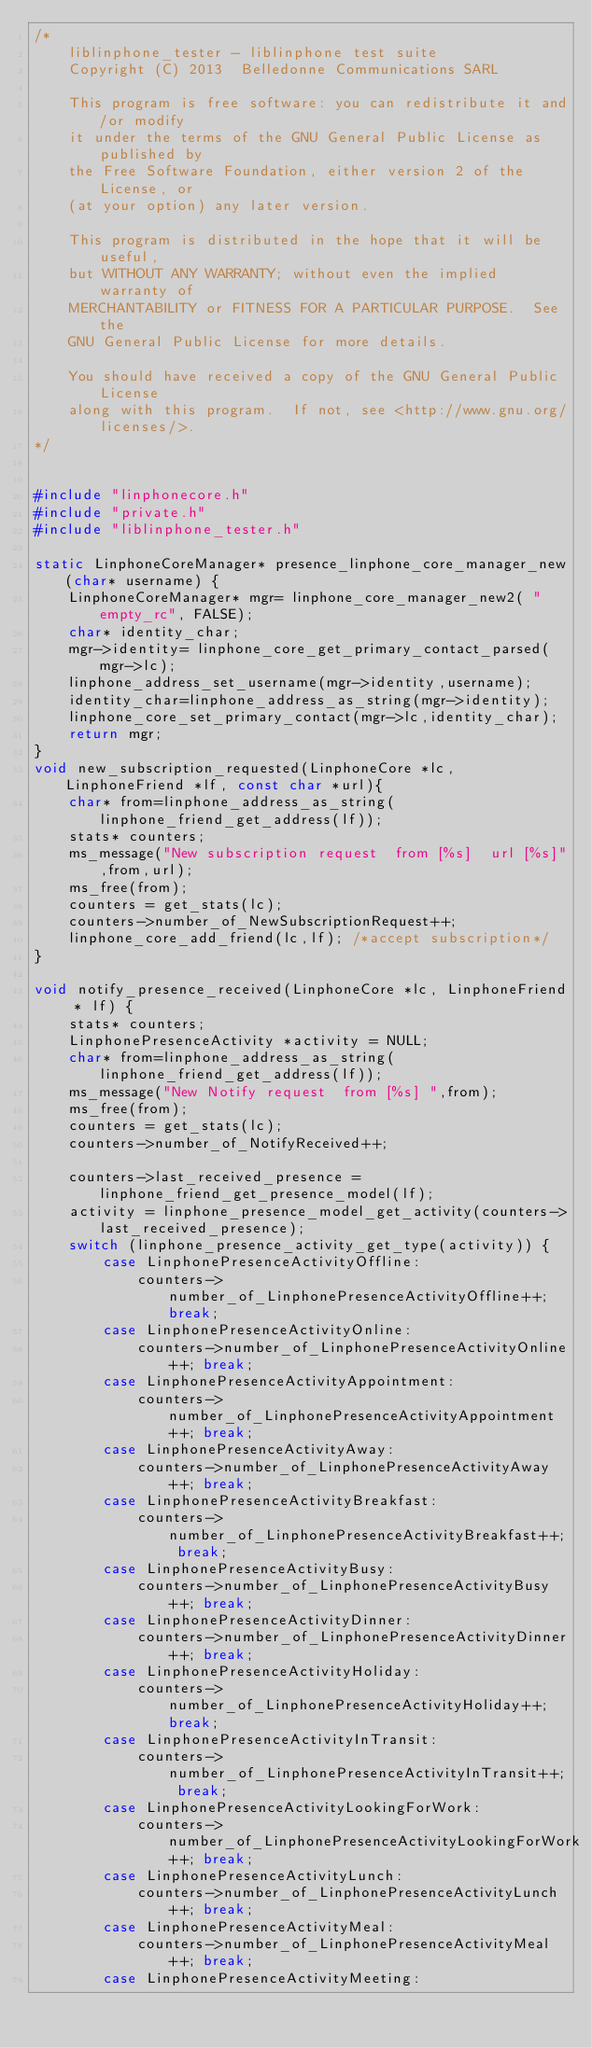<code> <loc_0><loc_0><loc_500><loc_500><_C_>/*
    liblinphone_tester - liblinphone test suite
    Copyright (C) 2013  Belledonne Communications SARL

    This program is free software: you can redistribute it and/or modify
    it under the terms of the GNU General Public License as published by
    the Free Software Foundation, either version 2 of the License, or
    (at your option) any later version.

    This program is distributed in the hope that it will be useful,
    but WITHOUT ANY WARRANTY; without even the implied warranty of
    MERCHANTABILITY or FITNESS FOR A PARTICULAR PURPOSE.  See the
    GNU General Public License for more details.

    You should have received a copy of the GNU General Public License
    along with this program.  If not, see <http://www.gnu.org/licenses/>.
*/


#include "linphonecore.h"
#include "private.h"
#include "liblinphone_tester.h"

static LinphoneCoreManager* presence_linphone_core_manager_new(char* username) {
	LinphoneCoreManager* mgr= linphone_core_manager_new2( "empty_rc", FALSE);
	char* identity_char;
	mgr->identity= linphone_core_get_primary_contact_parsed(mgr->lc);
	linphone_address_set_username(mgr->identity,username);
	identity_char=linphone_address_as_string(mgr->identity);
	linphone_core_set_primary_contact(mgr->lc,identity_char);
	return mgr;
}
void new_subscription_requested(LinphoneCore *lc, LinphoneFriend *lf, const char *url){
	char* from=linphone_address_as_string(linphone_friend_get_address(lf));
	stats* counters;
	ms_message("New subscription request  from [%s]  url [%s]",from,url);
	ms_free(from);
	counters = get_stats(lc);
	counters->number_of_NewSubscriptionRequest++;
	linphone_core_add_friend(lc,lf); /*accept subscription*/
}

void notify_presence_received(LinphoneCore *lc, LinphoneFriend * lf) {
	stats* counters;
	LinphonePresenceActivity *activity = NULL;
	char* from=linphone_address_as_string(linphone_friend_get_address(lf));
	ms_message("New Notify request  from [%s] ",from);
	ms_free(from);
	counters = get_stats(lc);
	counters->number_of_NotifyReceived++;

	counters->last_received_presence = linphone_friend_get_presence_model(lf);
	activity = linphone_presence_model_get_activity(counters->last_received_presence);
	switch (linphone_presence_activity_get_type(activity)) {
		case LinphonePresenceActivityOffline:
			counters->number_of_LinphonePresenceActivityOffline++; break;
		case LinphonePresenceActivityOnline:
			counters->number_of_LinphonePresenceActivityOnline++; break;
		case LinphonePresenceActivityAppointment:
			counters->number_of_LinphonePresenceActivityAppointment++; break;
		case LinphonePresenceActivityAway:
			counters->number_of_LinphonePresenceActivityAway++; break;
		case LinphonePresenceActivityBreakfast:
			counters->number_of_LinphonePresenceActivityBreakfast++; break;
		case LinphonePresenceActivityBusy:
			counters->number_of_LinphonePresenceActivityBusy++; break;
		case LinphonePresenceActivityDinner:
			counters->number_of_LinphonePresenceActivityDinner++; break;
		case LinphonePresenceActivityHoliday:
			counters->number_of_LinphonePresenceActivityHoliday++; break;
		case LinphonePresenceActivityInTransit:
			counters->number_of_LinphonePresenceActivityInTransit++; break;
		case LinphonePresenceActivityLookingForWork:
			counters->number_of_LinphonePresenceActivityLookingForWork++; break;
		case LinphonePresenceActivityLunch:
			counters->number_of_LinphonePresenceActivityLunch++; break;
		case LinphonePresenceActivityMeal:
			counters->number_of_LinphonePresenceActivityMeal++; break;
		case LinphonePresenceActivityMeeting:</code> 